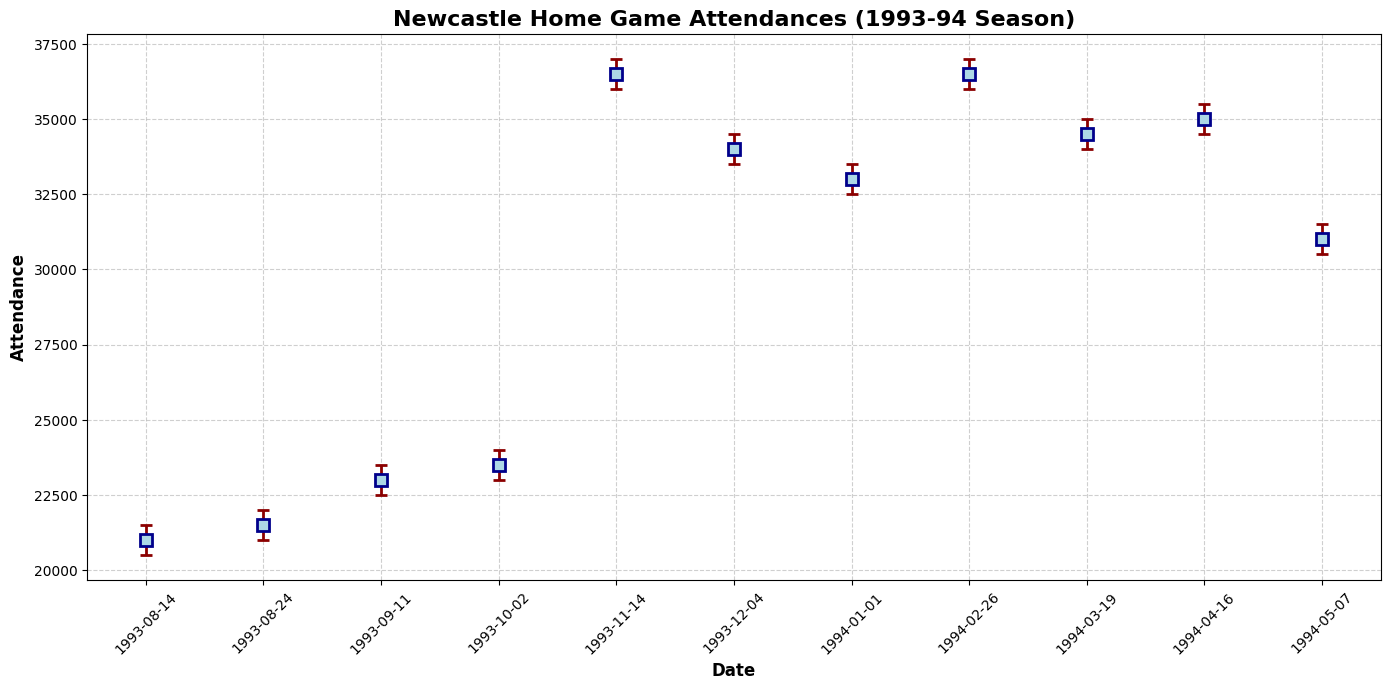What is the date with the highest attendance? To find the date with the highest attendance, look for the data point with the largest value on the y-axis. The highest attendance is seen for the match Newcastle vs Manchester United on November 14, 1993.
Answer: November 14, 1993 Between the matches against Coventry and Aston Villa, which had the smaller attendance? Look at the attendance figures for matches Newcastle vs Coventry (August 14, 1993) and Newcastle vs Aston Villa (April 16, 1994). Coventry had 21,000, and Aston Villa had 35,000.
Answer: Coventry What is the difference in attendance between the match against Sheffield Wednesday and the match against Liverpool? Identify the attendance for Newcastle vs Sheffield Wednesday (August 24, 1993) which is 21,500 and the match against Liverpool (February 26, 1994) which is 36,500. Subtract 21,500 from 36,500 to get the difference. 36,500 - 21,500 = 15,000.
Answer: 15,000 How many matches had an attendance of more than 32,000? Evaluate each match's attendance and count those greater than 32,000. The matches are: Manchester United (36,500), Arsenal (34,000), Chelsea (33,000), Liverpool (36,500), Leeds (34,500), Aston Villa (35,000), and Swindon (31,000). Total is 6.
Answer: 6 Which match had the lowest attendance and what was it? Check all attendance figures and find the lowest value. The match with the lowest attendance is Newcastle vs Coventry (August 14, 1993) with 21,000 attendees.
Answer: Newcastle vs Coventry, 21,000 For the matches against Chelsea, Leeds, and Aston Villa, what is the average attendance? Find the attendance for Chelsea (33,000), Leeds (34,500), and Aston Villa (35,000). Sum these values and divide by 3 to get the average. (33,000 + 34,500 + 35,000) / 3 = 34,166.67.
Answer: 34,166.67 Are there any matches where the upper bound of the confidence interval did not exceed 22,000? Review the upper bound values and find any that do not exceed 22,000. The matches against Coventry (21,500) and Sheffield Wednesday (22,000) meet this criterion.
Answer: Yes 